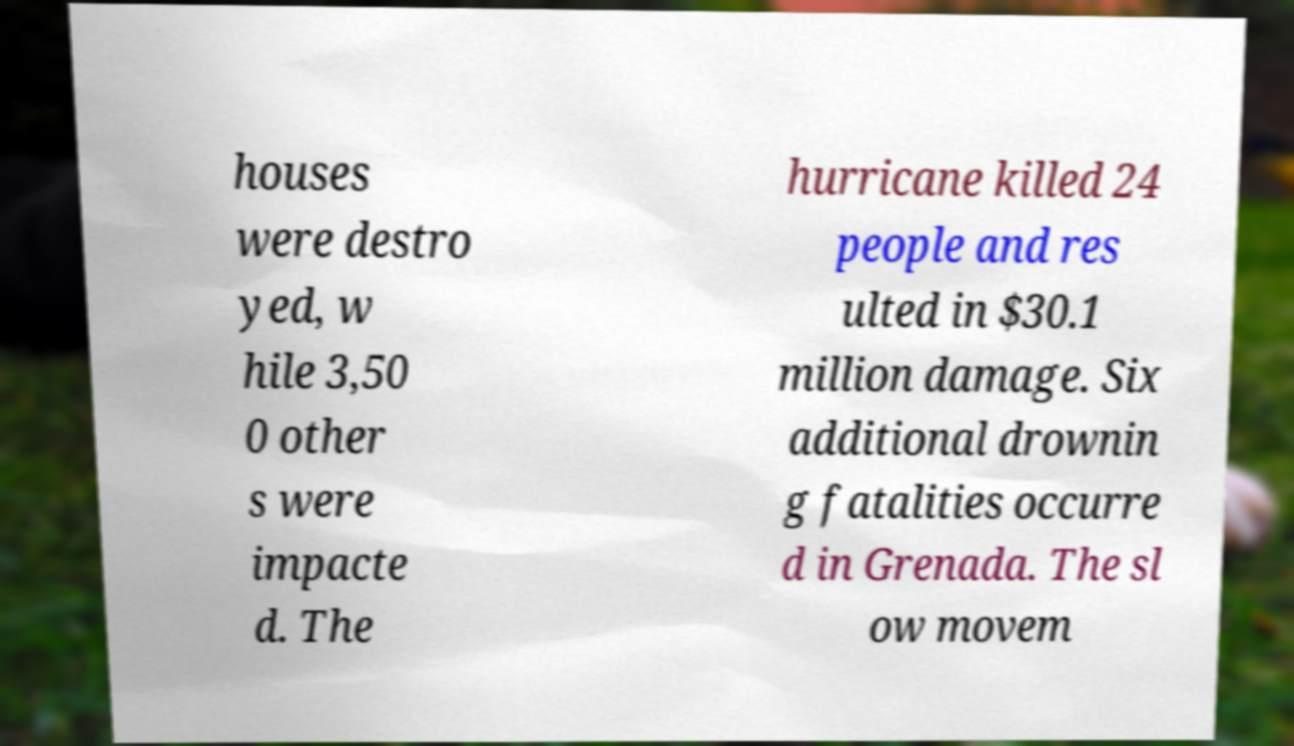I need the written content from this picture converted into text. Can you do that? houses were destro yed, w hile 3,50 0 other s were impacte d. The hurricane killed 24 people and res ulted in $30.1 million damage. Six additional drownin g fatalities occurre d in Grenada. The sl ow movem 